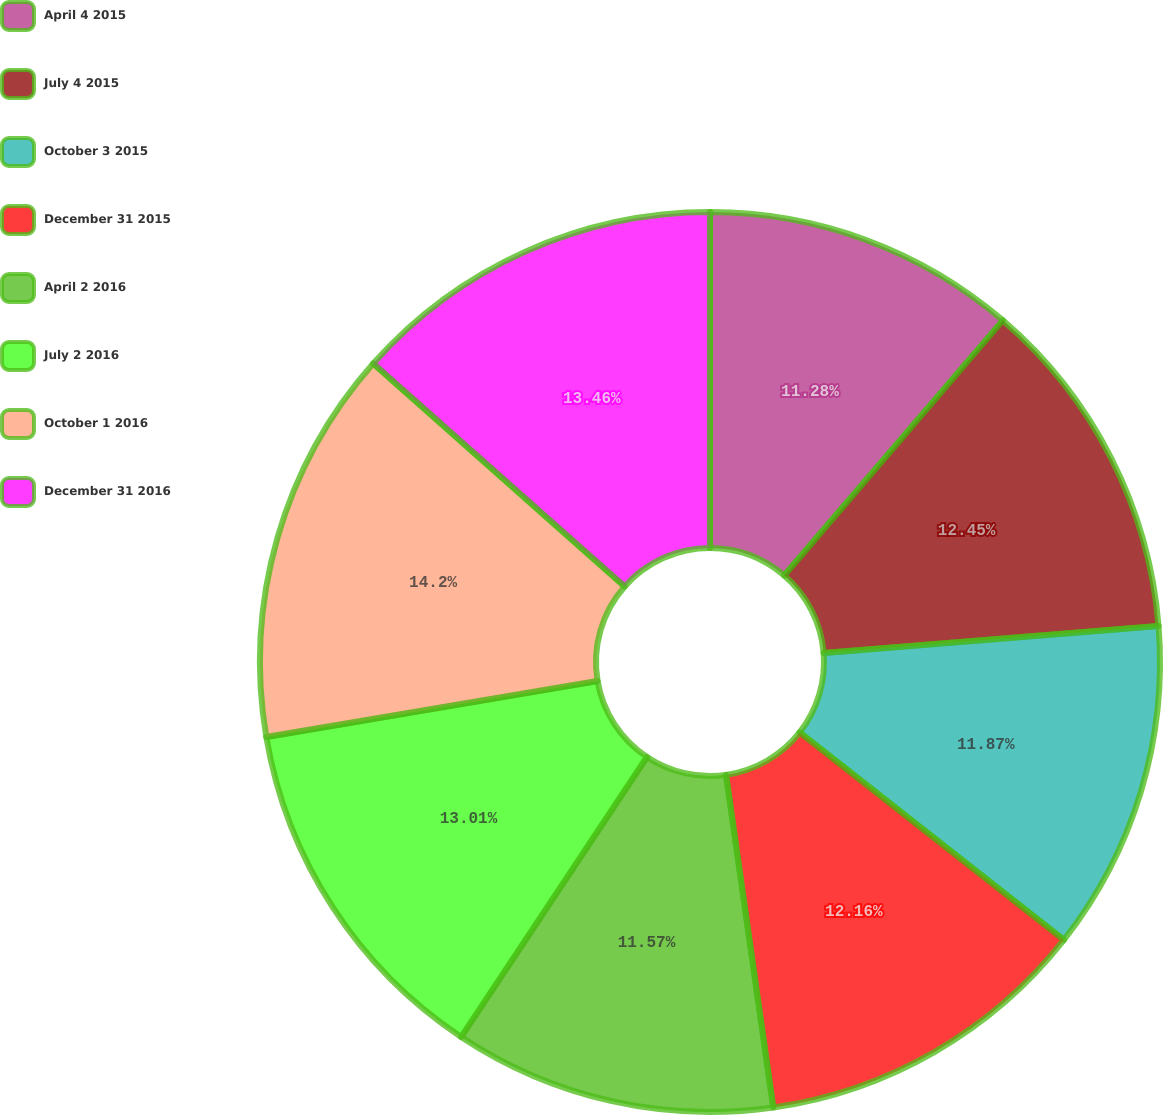<chart> <loc_0><loc_0><loc_500><loc_500><pie_chart><fcel>April 4 2015<fcel>July 4 2015<fcel>October 3 2015<fcel>December 31 2015<fcel>April 2 2016<fcel>July 2 2016<fcel>October 1 2016<fcel>December 31 2016<nl><fcel>11.28%<fcel>12.45%<fcel>11.87%<fcel>12.16%<fcel>11.57%<fcel>13.01%<fcel>14.21%<fcel>13.46%<nl></chart> 